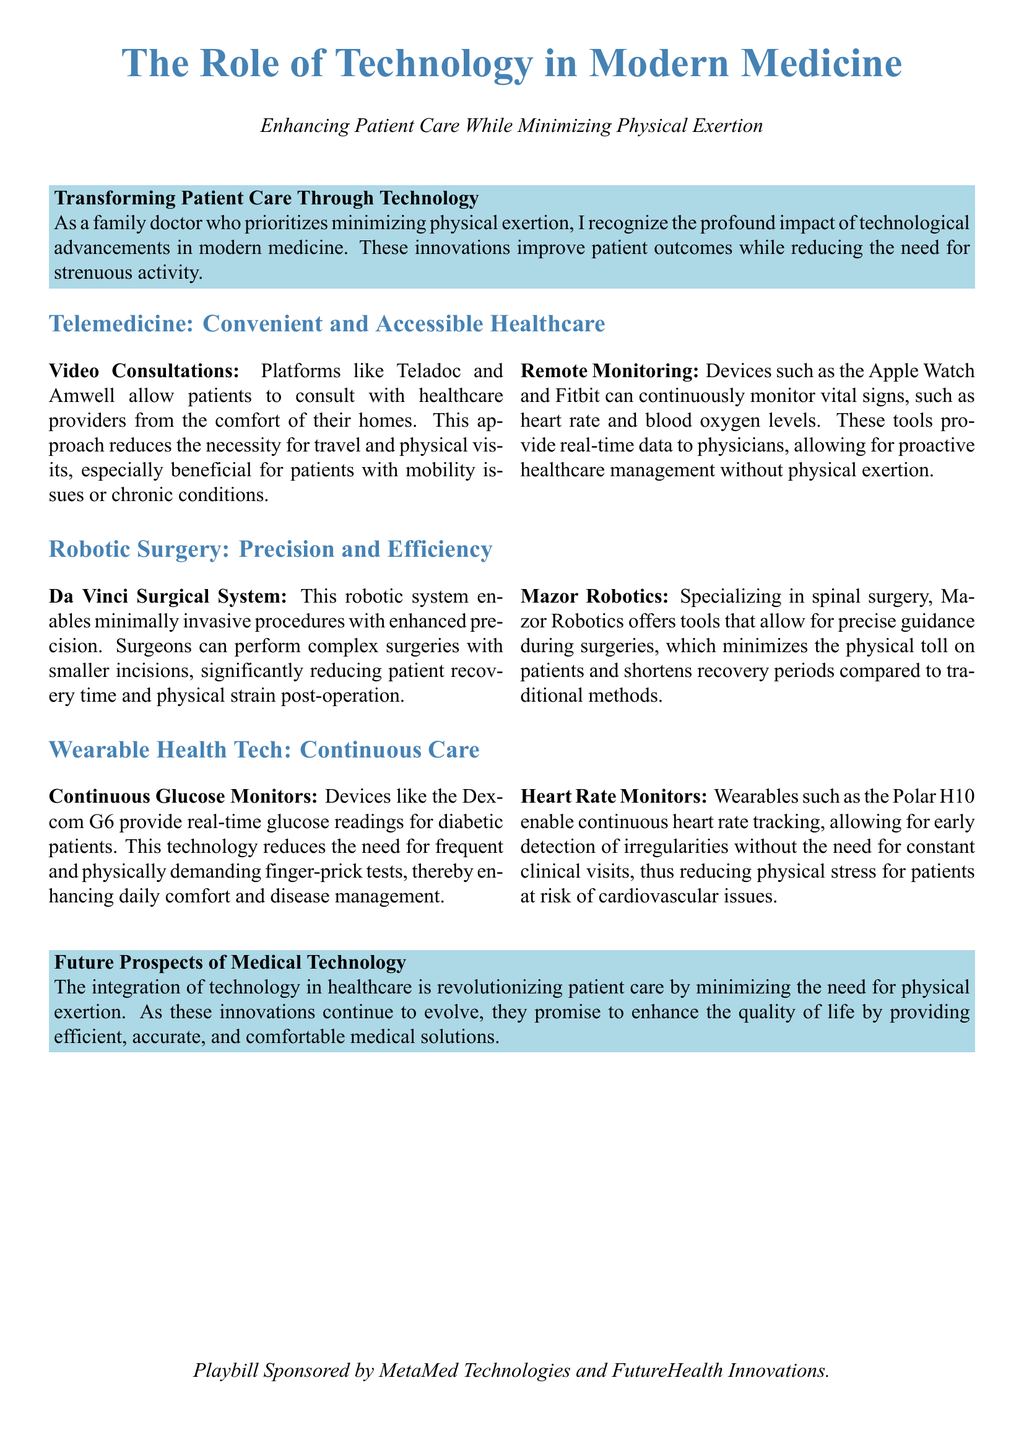What technology allows patients to consult healthcare providers from home? The document mentions telemedicine platforms like Teladoc and Amwell, which enable video consultations from home.
Answer: Telemedicine platforms What is the name of the robotic system enabling minimally invasive procedures? The document refers to the Da Vinci Surgical System, known for enhancing precision in surgeries.
Answer: Da Vinci Surgical System Which device continuously monitors glucose levels for diabetic patients? The document highlights the Dexcom G6 as a continuous glucose monitor.
Answer: Dexcom G6 What type of robot specializes in spinal surgery? The document mentions Mazor Robotics as specializing in spinal surgeries.
Answer: Mazor Robotics What feature do wearable health technologies facilitate that reduces the need for clinical visits? The document states that heart rate monitors enable continuous heart rate tracking, allowing early detection of irregularities.
Answer: Continuous heart rate tracking How does the integration of technology in healthcare impact physical exertion needs? The document discusses how technological advancements minimize the need for physical exertion in patient care.
Answer: Minimizes physical exertion What color is used for section headers in this Playbill document? The document uses medblue color for the section headers to distinguish them.
Answer: Medblue Who sponsored the playbill? The document credits MetaMed Technologies and FutureHealth Innovations as the sponsors.
Answer: MetaMed Technologies and FutureHealth Innovations 